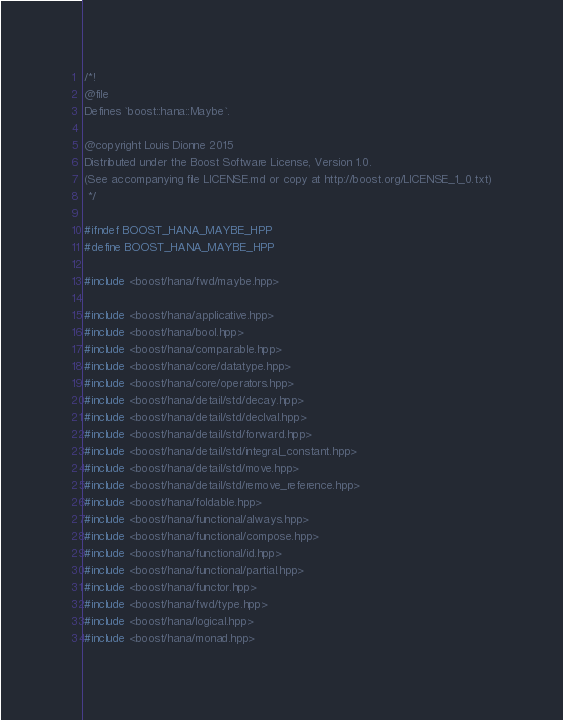Convert code to text. <code><loc_0><loc_0><loc_500><loc_500><_C++_>/*!
@file
Defines `boost::hana::Maybe`.

@copyright Louis Dionne 2015
Distributed under the Boost Software License, Version 1.0.
(See accompanying file LICENSE.md or copy at http://boost.org/LICENSE_1_0.txt)
 */

#ifndef BOOST_HANA_MAYBE_HPP
#define BOOST_HANA_MAYBE_HPP

#include <boost/hana/fwd/maybe.hpp>

#include <boost/hana/applicative.hpp>
#include <boost/hana/bool.hpp>
#include <boost/hana/comparable.hpp>
#include <boost/hana/core/datatype.hpp>
#include <boost/hana/core/operators.hpp>
#include <boost/hana/detail/std/decay.hpp>
#include <boost/hana/detail/std/declval.hpp>
#include <boost/hana/detail/std/forward.hpp>
#include <boost/hana/detail/std/integral_constant.hpp>
#include <boost/hana/detail/std/move.hpp>
#include <boost/hana/detail/std/remove_reference.hpp>
#include <boost/hana/foldable.hpp>
#include <boost/hana/functional/always.hpp>
#include <boost/hana/functional/compose.hpp>
#include <boost/hana/functional/id.hpp>
#include <boost/hana/functional/partial.hpp>
#include <boost/hana/functor.hpp>
#include <boost/hana/fwd/type.hpp>
#include <boost/hana/logical.hpp>
#include <boost/hana/monad.hpp></code> 